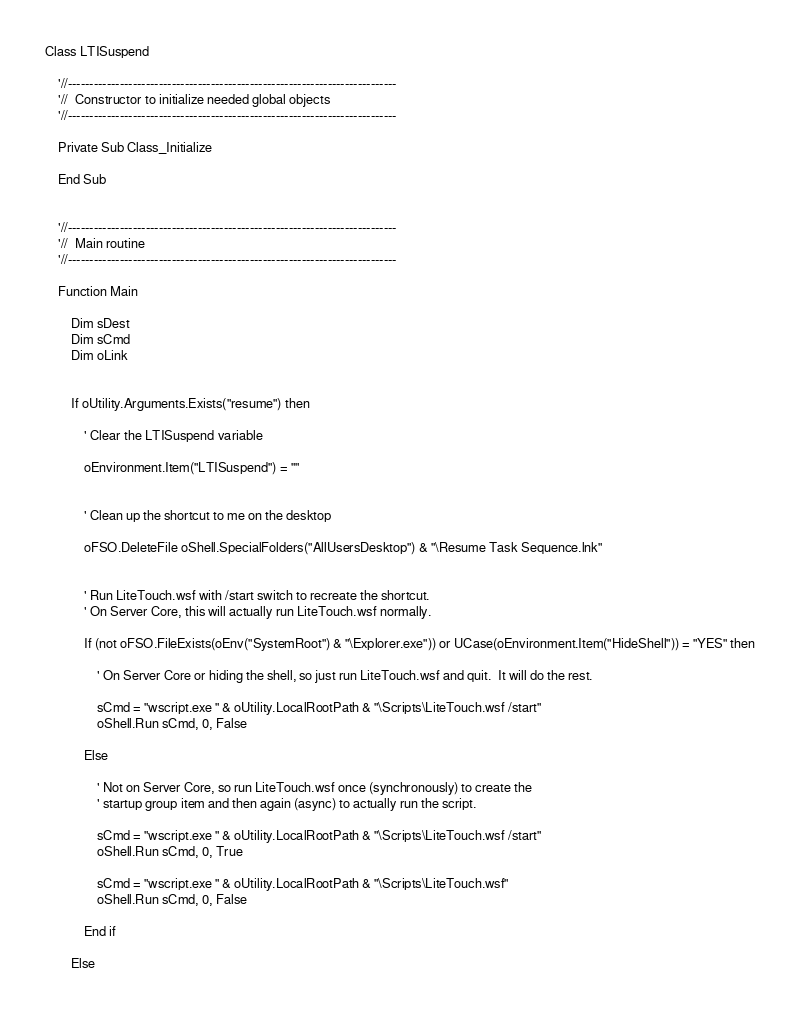<code> <loc_0><loc_0><loc_500><loc_500><_XML_>
Class LTISuspend

	'//----------------------------------------------------------------------------
	'//  Constructor to initialize needed global objects
	'//----------------------------------------------------------------------------

	Private Sub Class_Initialize

	End Sub


	'//----------------------------------------------------------------------------
	'//  Main routine
	'//----------------------------------------------------------------------------

	Function Main

		Dim sDest
		Dim sCmd 
		Dim oLink


		If oUtility.Arguments.Exists("resume") then

			' Clear the LTISuspend variable

			oEnvironment.Item("LTISuspend") = ""


			' Clean up the shortcut to me on the desktop

			oFSO.DeleteFile oShell.SpecialFolders("AllUsersDesktop") & "\Resume Task Sequence.lnk"


			' Run LiteTouch.wsf with /start switch to recreate the shortcut.
			' On Server Core, this will actually run LiteTouch.wsf normally.

			If (not oFSO.FileExists(oEnv("SystemRoot") & "\Explorer.exe")) or UCase(oEnvironment.Item("HideShell")) = "YES" then

				' On Server Core or hiding the shell, so just run LiteTouch.wsf and quit.  It will do the rest.

				sCmd = "wscript.exe " & oUtility.LocalRootPath & "\Scripts\LiteTouch.wsf /start"
				oShell.Run sCmd, 0, False

			Else

				' Not on Server Core, so run LiteTouch.wsf once (synchronously) to create the 
				' startup group item and then again (async) to actually run the script.

				sCmd = "wscript.exe " & oUtility.LocalRootPath & "\Scripts\LiteTouch.wsf /start"
				oShell.Run sCmd, 0, True

				sCmd = "wscript.exe " & oUtility.LocalRootPath & "\Scripts\LiteTouch.wsf"
				oShell.Run sCmd, 0, False

			End if				

		Else
		</code> 